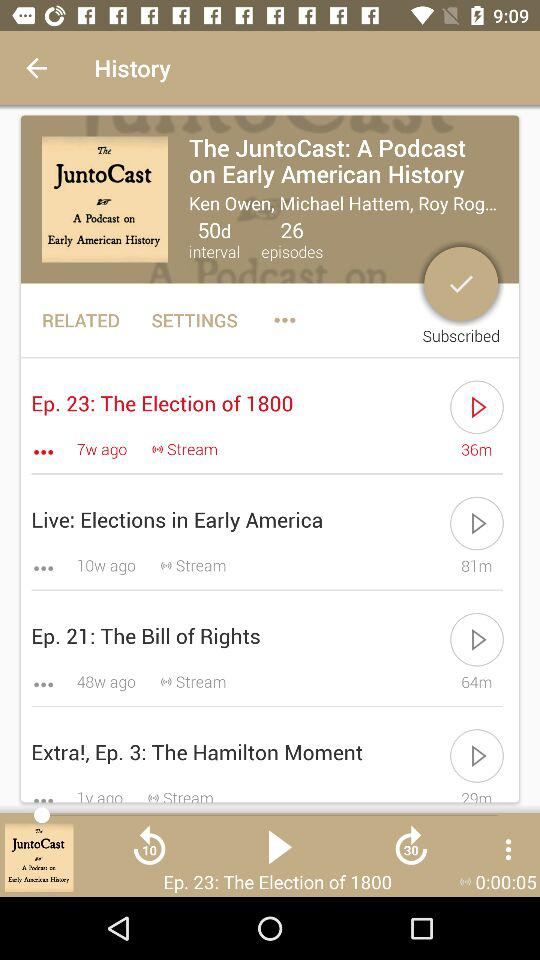How many episodes have been published in the last 2 months?
Answer the question using a single word or phrase. 2 